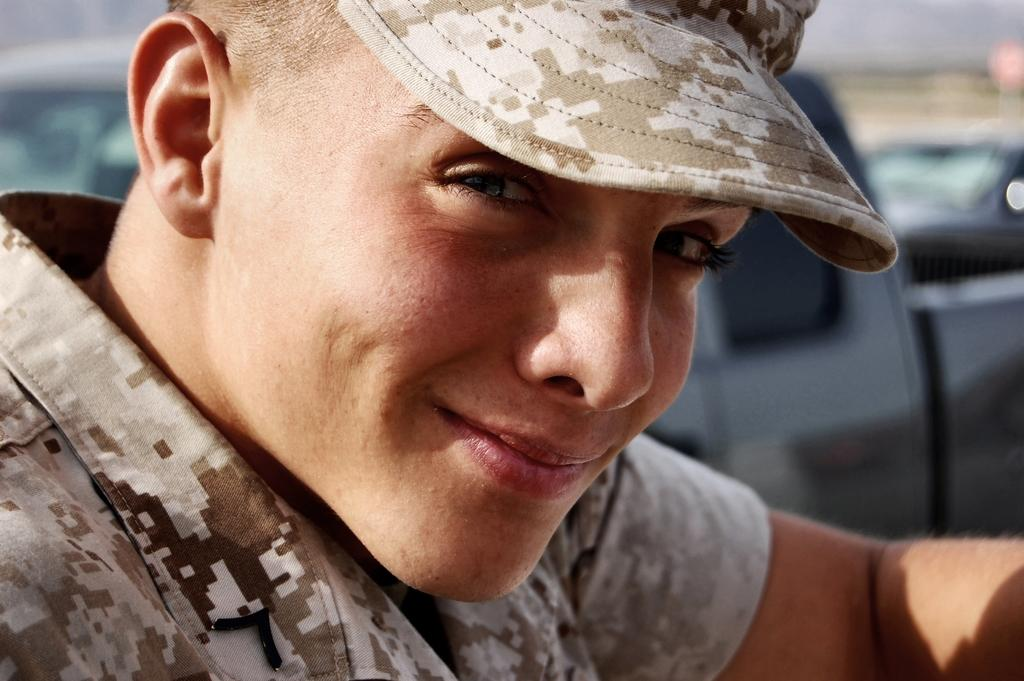Who is present in the image? There is a man in the image. What is the man wearing on his head? The man is wearing a hat. Can you describe the background of the image? The background of the image is blurred. What is the man's opinion on the porter's service in the image? There is no indication of the man's opinion on the porter's service in the image, nor is there any reference to a porter. 